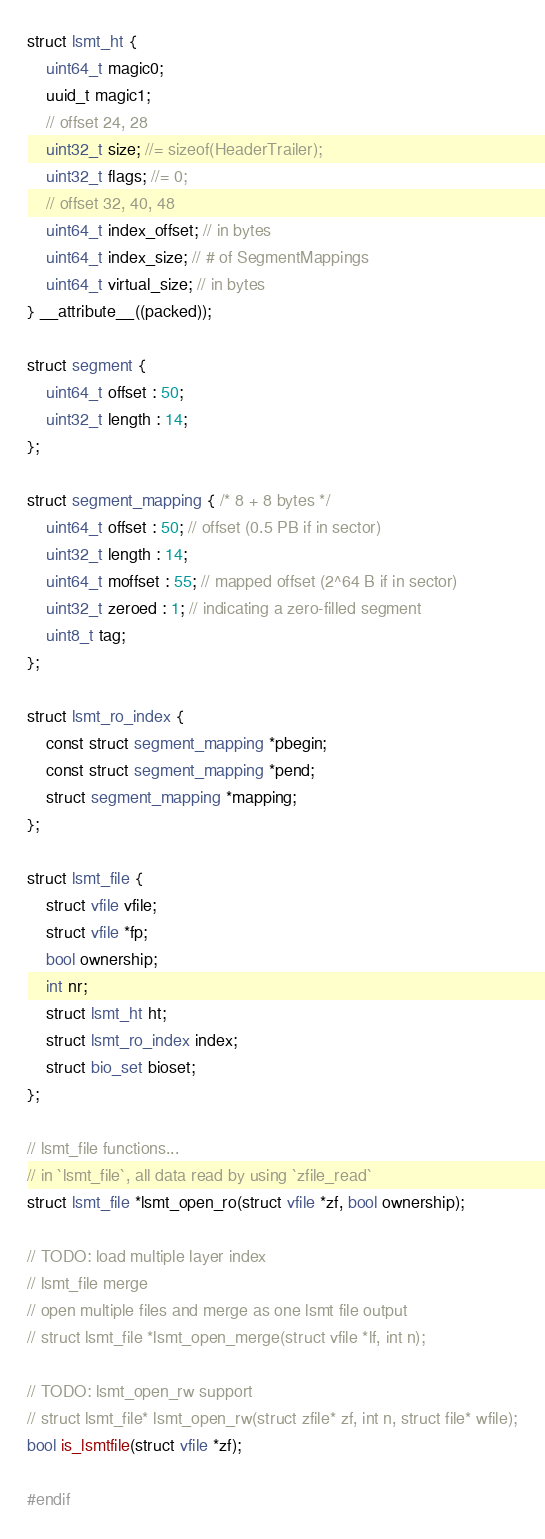Convert code to text. <code><loc_0><loc_0><loc_500><loc_500><_C_>struct lsmt_ht {
	uint64_t magic0;
	uuid_t magic1;
	// offset 24, 28
	uint32_t size; //= sizeof(HeaderTrailer);
	uint32_t flags; //= 0;
	// offset 32, 40, 48
	uint64_t index_offset; // in bytes
	uint64_t index_size; // # of SegmentMappings
	uint64_t virtual_size; // in bytes
} __attribute__((packed));

struct segment {
	uint64_t offset : 50;
	uint32_t length : 14;
};

struct segment_mapping { /* 8 + 8 bytes */
	uint64_t offset : 50; // offset (0.5 PB if in sector)
	uint32_t length : 14;
	uint64_t moffset : 55; // mapped offset (2^64 B if in sector)
	uint32_t zeroed : 1; // indicating a zero-filled segment
	uint8_t tag;
};

struct lsmt_ro_index {
	const struct segment_mapping *pbegin;
	const struct segment_mapping *pend;
	struct segment_mapping *mapping;
};

struct lsmt_file {
	struct vfile vfile;
	struct vfile *fp;
	bool ownership;
	int nr;
	struct lsmt_ht ht;
	struct lsmt_ro_index index;
	struct bio_set bioset;
};

// lsmt_file functions...
// in `lsmt_file`, all data read by using `zfile_read`
struct lsmt_file *lsmt_open_ro(struct vfile *zf, bool ownership);

// TODO: load multiple layer index
// lsmt_file merge
// open multiple files and merge as one lsmt file output
// struct lsmt_file *lsmt_open_merge(struct vfile *lf, int n);

// TODO: lsmt_open_rw support
// struct lsmt_file* lsmt_open_rw(struct zfile* zf, int n, struct file* wfile);
bool is_lsmtfile(struct vfile *zf);

#endif</code> 